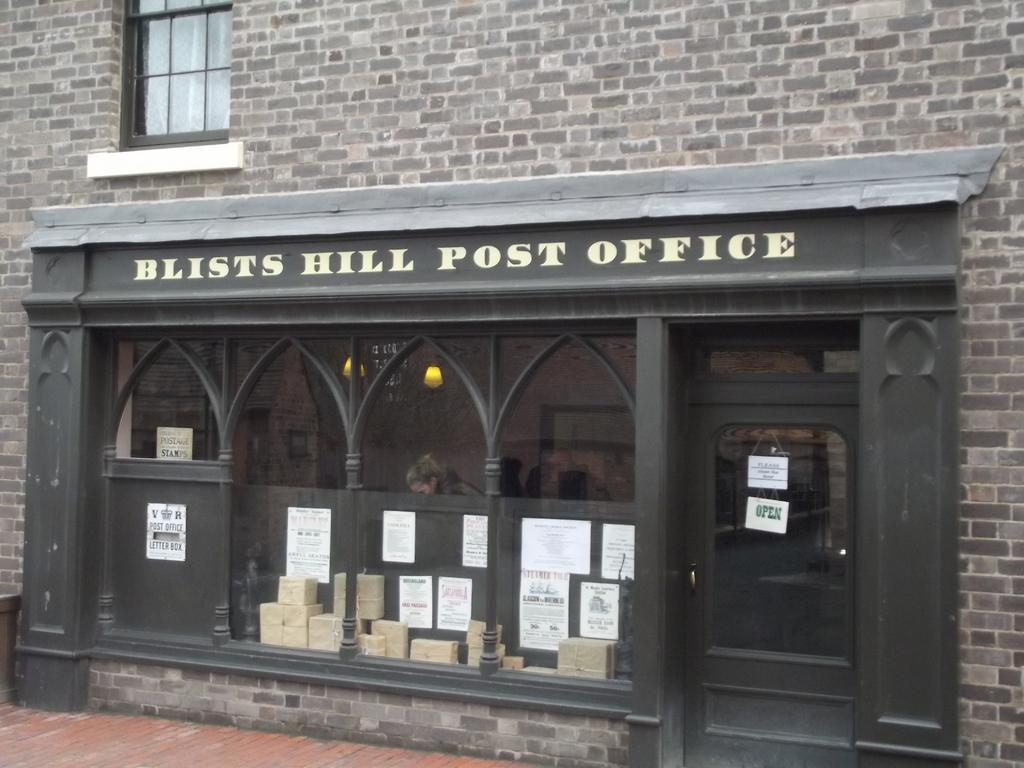What is the main structure in the image? There is a building in the center of the image. What features can be seen on the building? The building has a door and a window. Are there any objects or items placed on the building? Papers are placed on the wall. What type of friction can be observed between the bat and the dinosaurs in the image? There are no bats or dinosaurs present in the image, so there is no friction to observe between them. 